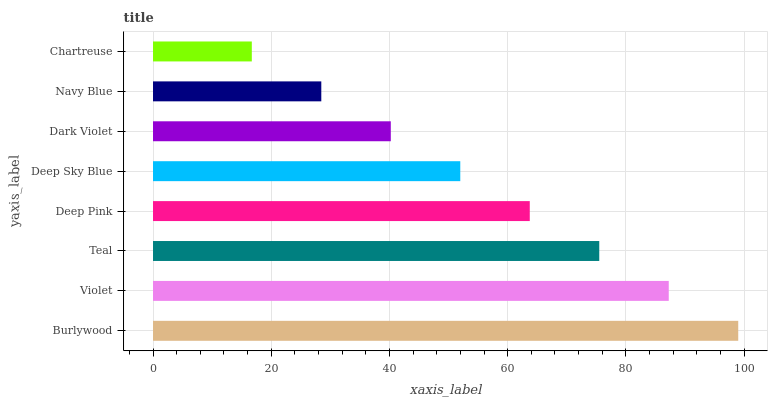Is Chartreuse the minimum?
Answer yes or no. Yes. Is Burlywood the maximum?
Answer yes or no. Yes. Is Violet the minimum?
Answer yes or no. No. Is Violet the maximum?
Answer yes or no. No. Is Burlywood greater than Violet?
Answer yes or no. Yes. Is Violet less than Burlywood?
Answer yes or no. Yes. Is Violet greater than Burlywood?
Answer yes or no. No. Is Burlywood less than Violet?
Answer yes or no. No. Is Deep Pink the high median?
Answer yes or no. Yes. Is Deep Sky Blue the low median?
Answer yes or no. Yes. Is Burlywood the high median?
Answer yes or no. No. Is Violet the low median?
Answer yes or no. No. 